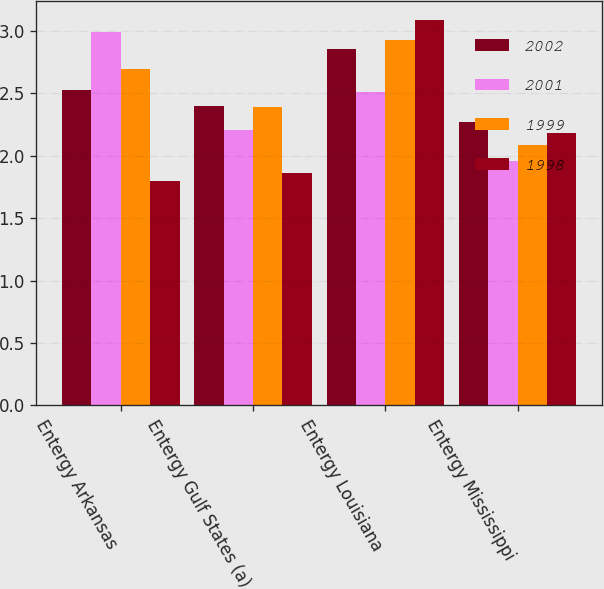Convert chart. <chart><loc_0><loc_0><loc_500><loc_500><stacked_bar_chart><ecel><fcel>Entergy Arkansas<fcel>Entergy Gulf States (a)<fcel>Entergy Louisiana<fcel>Entergy Mississippi<nl><fcel>2002<fcel>2.53<fcel>2.4<fcel>2.86<fcel>2.27<nl><fcel>2001<fcel>2.99<fcel>2.21<fcel>2.51<fcel>1.96<nl><fcel>1999<fcel>2.7<fcel>2.39<fcel>2.93<fcel>2.09<nl><fcel>1998<fcel>1.8<fcel>1.86<fcel>3.09<fcel>2.18<nl></chart> 